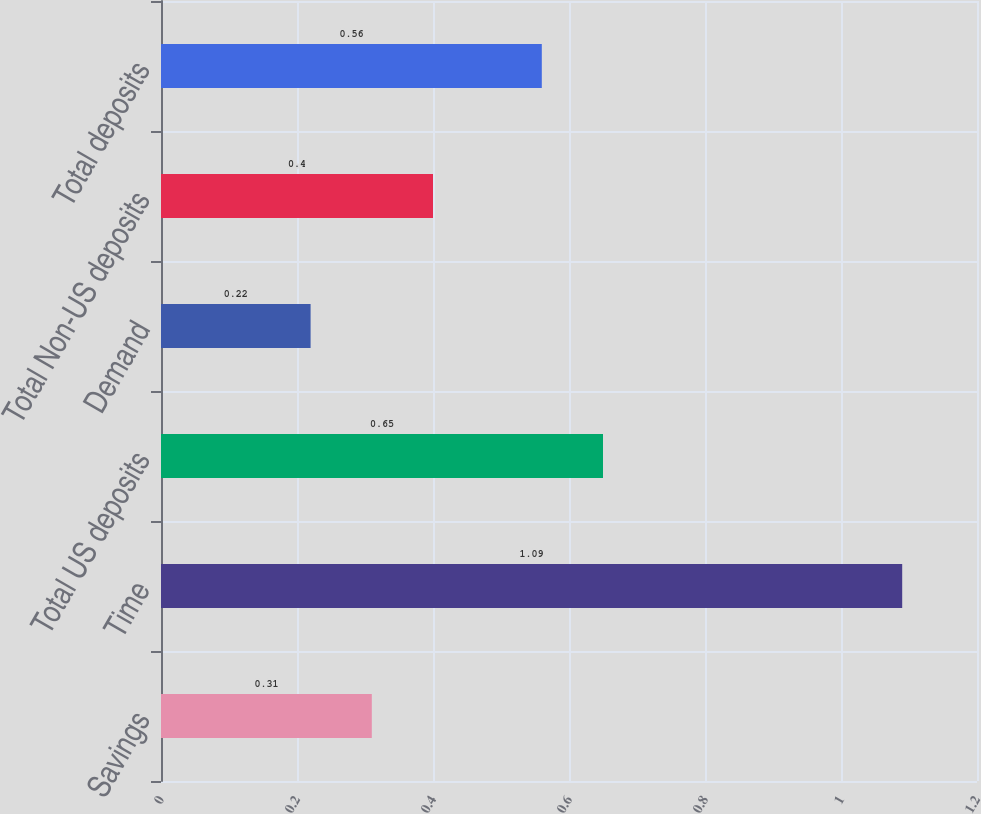Convert chart. <chart><loc_0><loc_0><loc_500><loc_500><bar_chart><fcel>Savings<fcel>Time<fcel>Total US deposits<fcel>Demand<fcel>Total Non-US deposits<fcel>Total deposits<nl><fcel>0.31<fcel>1.09<fcel>0.65<fcel>0.22<fcel>0.4<fcel>0.56<nl></chart> 